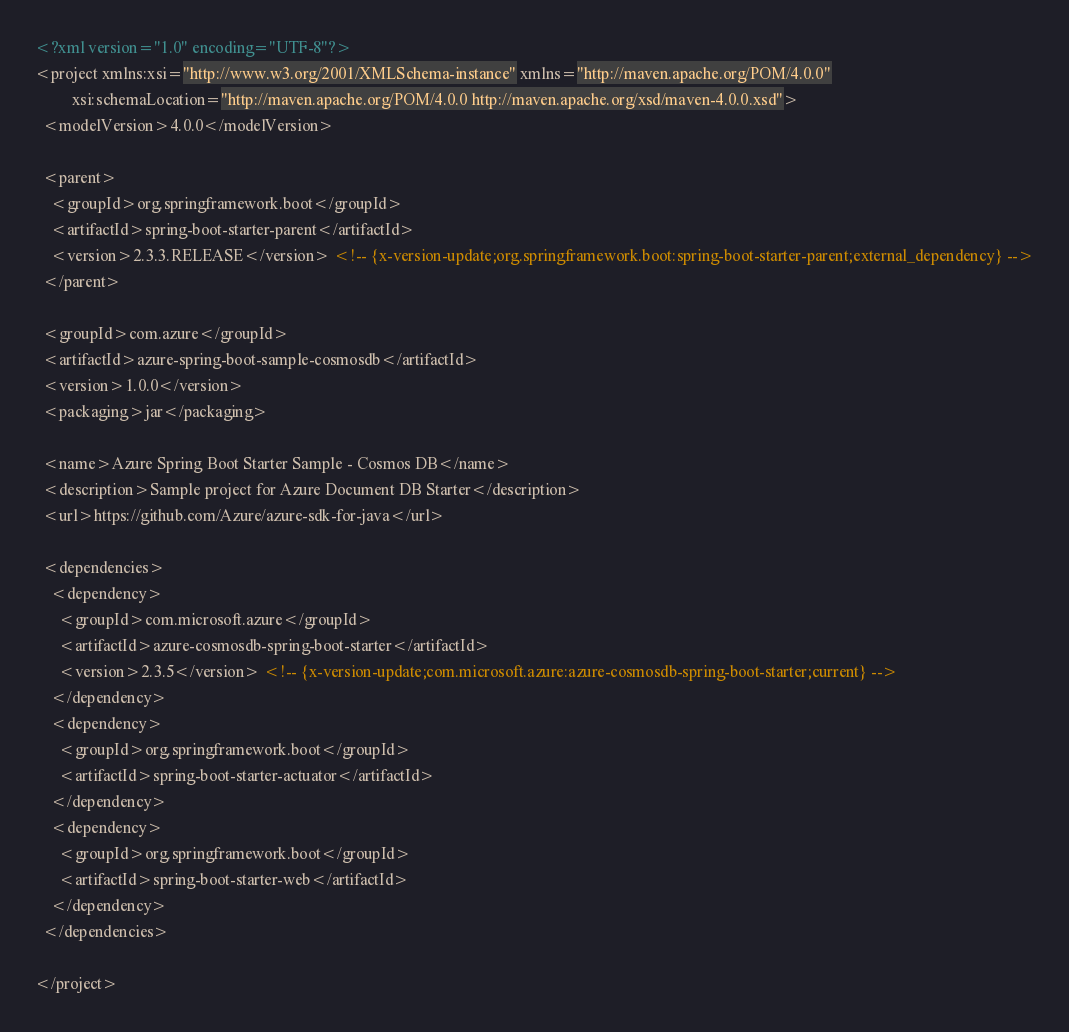Convert code to text. <code><loc_0><loc_0><loc_500><loc_500><_XML_><?xml version="1.0" encoding="UTF-8"?>
<project xmlns:xsi="http://www.w3.org/2001/XMLSchema-instance" xmlns="http://maven.apache.org/POM/4.0.0"
         xsi:schemaLocation="http://maven.apache.org/POM/4.0.0 http://maven.apache.org/xsd/maven-4.0.0.xsd">
  <modelVersion>4.0.0</modelVersion>

  <parent>
    <groupId>org.springframework.boot</groupId>
    <artifactId>spring-boot-starter-parent</artifactId>
    <version>2.3.3.RELEASE</version> <!-- {x-version-update;org.springframework.boot:spring-boot-starter-parent;external_dependency} -->
  </parent>

  <groupId>com.azure</groupId>
  <artifactId>azure-spring-boot-sample-cosmosdb</artifactId>
  <version>1.0.0</version>
  <packaging>jar</packaging>

  <name>Azure Spring Boot Starter Sample - Cosmos DB</name>
  <description>Sample project for Azure Document DB Starter</description>
  <url>https://github.com/Azure/azure-sdk-for-java</url>

  <dependencies>
    <dependency>
      <groupId>com.microsoft.azure</groupId>
      <artifactId>azure-cosmosdb-spring-boot-starter</artifactId>
      <version>2.3.5</version> <!-- {x-version-update;com.microsoft.azure:azure-cosmosdb-spring-boot-starter;current} -->
    </dependency>
    <dependency>
      <groupId>org.springframework.boot</groupId>
      <artifactId>spring-boot-starter-actuator</artifactId>
    </dependency>
    <dependency>
      <groupId>org.springframework.boot</groupId>
      <artifactId>spring-boot-starter-web</artifactId>
    </dependency>
  </dependencies>

</project>
</code> 